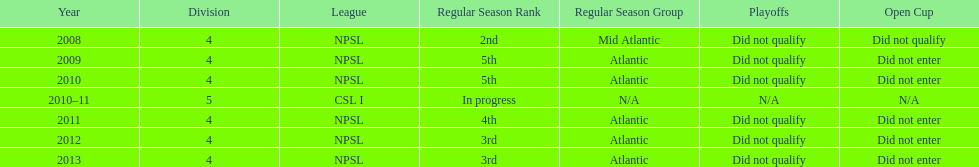How many years did they not qualify for the playoffs? 6. 